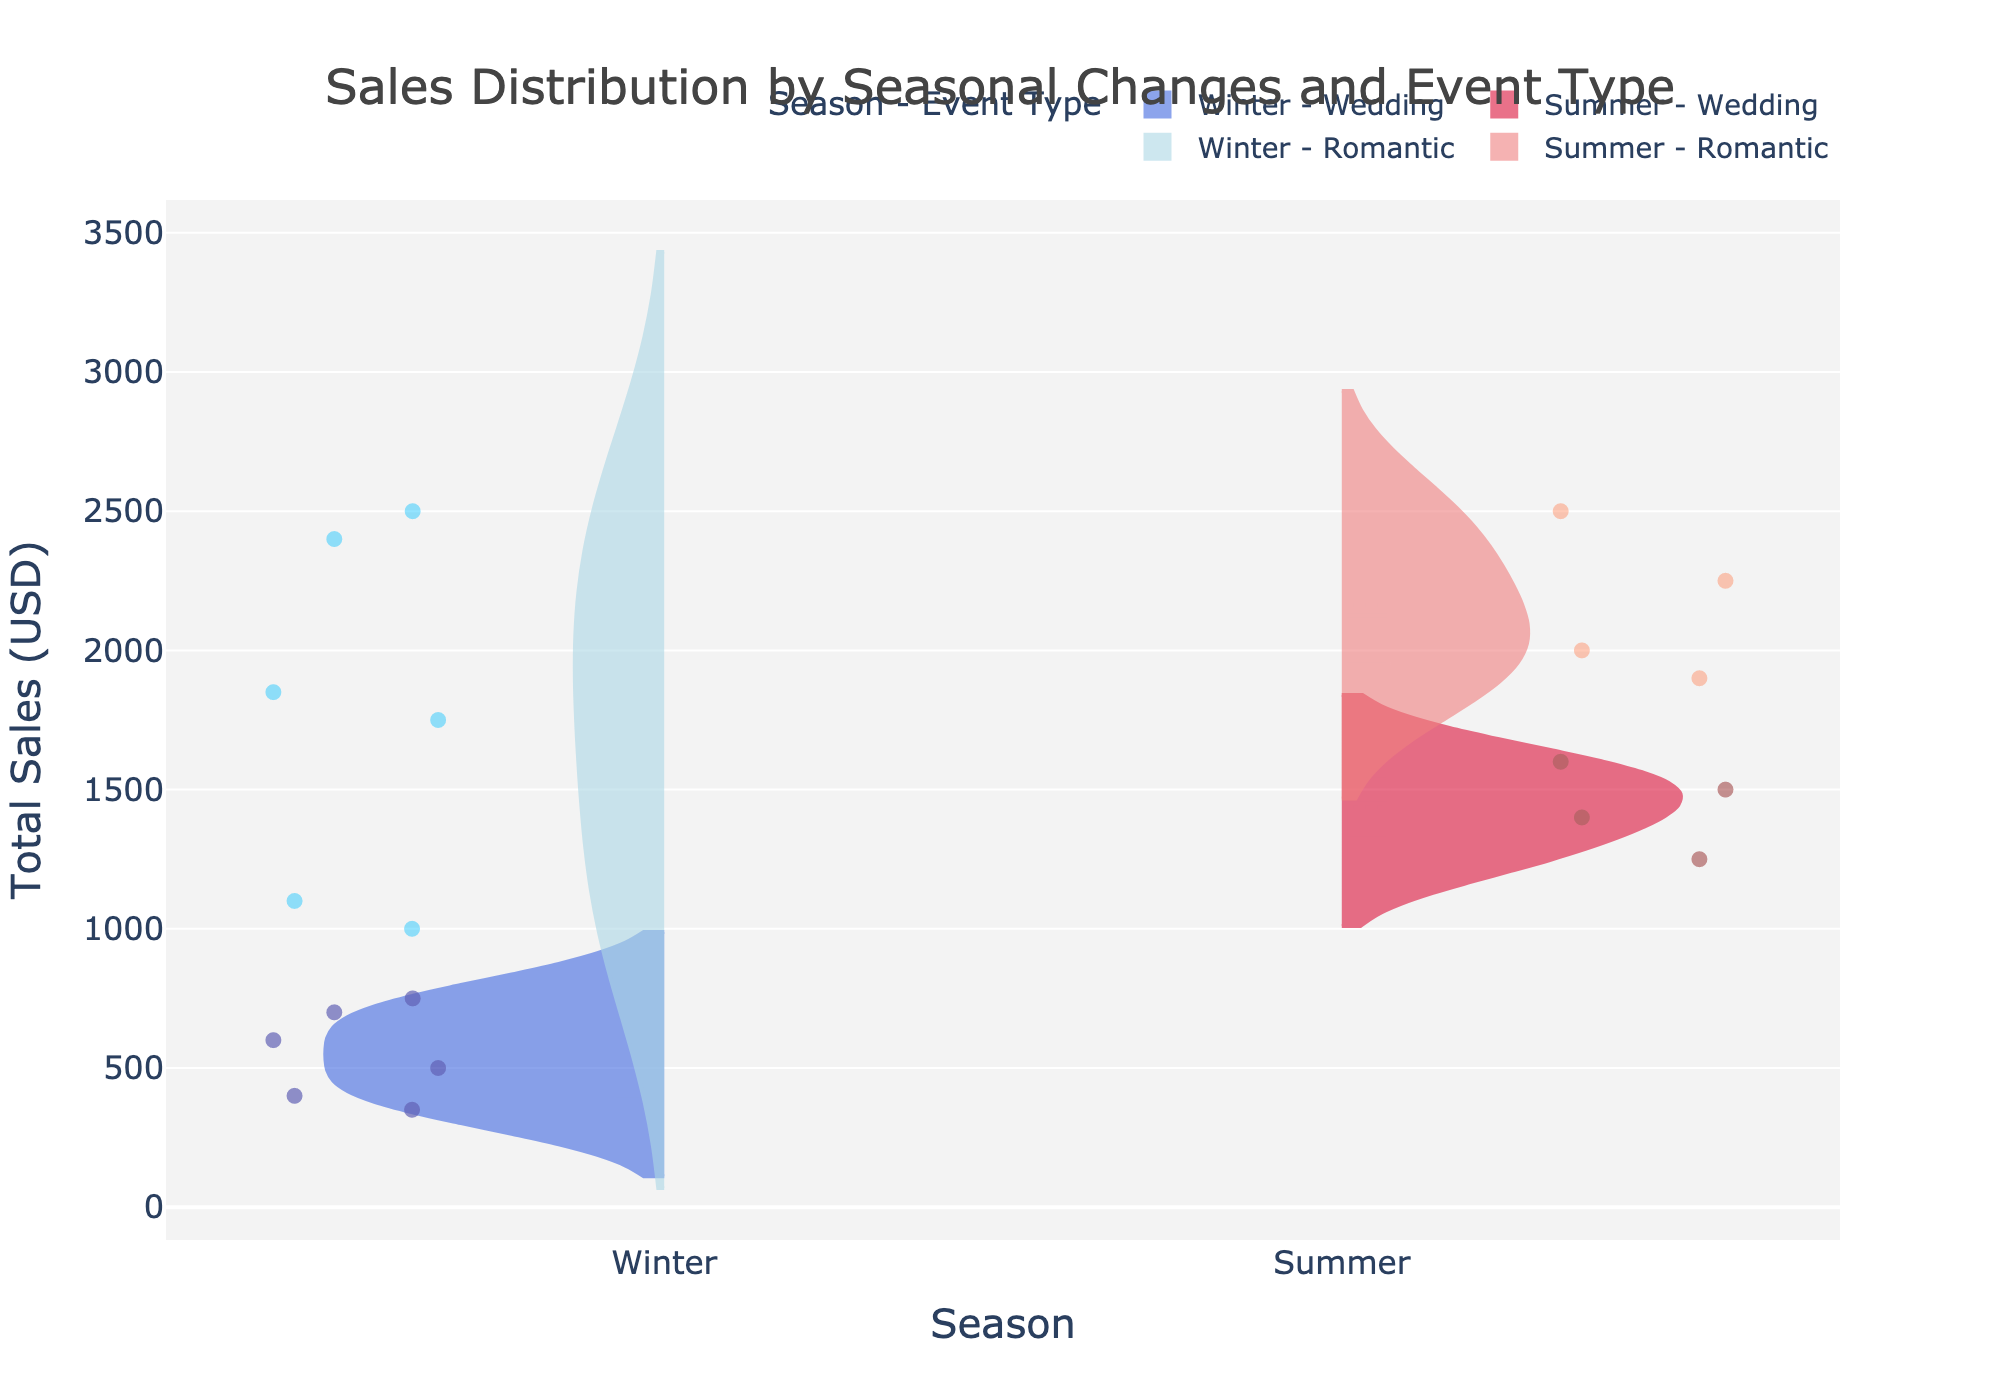What's the title of the figure? The title is found at the top center of the figure, usually in a larger font size.
Answer: Sales Distribution by Seasonal Changes and Event Type What is the axis title for the x-axis? The x-axis title is located below the horizontal axis of the figure and describes the variable represented by this axis.
Answer: Season What colors represent the Wedding sales in Winter and Summer? Winter Wedding sales are shown in royal blue, and Summer Wedding sales are shown in crimson.
Answer: Royal blue (Winter), Crimson (Summer) Which season generally shows higher total sales for Romantic events? By visually comparing the density and spread of the violin plots, Summer has a higher distribution indicating higher sales for Romantic events.
Answer: Summer How does the distribution of Wedding sales in Winter compare to Wedding sales in Summer? In the figure, Winter Wedding sales have a more concentrated distribution with less spread compared to the wider distribution in Summer Wedding sales.
Answer: Winter is more concentrated, Summer is more spread out Which combination shows the highest individual total sales value, and what is that value? By looking at the highest points within each violin, the highest value is in Winter Romantic events on February 14th with $2,500.
Answer: Winter Romantic, $2,500 How do the mean lines for Romantic event sales compare between Winter and Summer? The mean lines are visible within each violin plot. The mean line for Romantic sales in Summer is higher than that in Winter, indicating higher average sales in Summer.
Answer: Summer is higher than Winter For which event type and season is the total sales distribution most spread out? The spread or width of the violin plots indicates distribution. Romantic events in Summer show the most spread out distribution.
Answer: Summer Romantic 